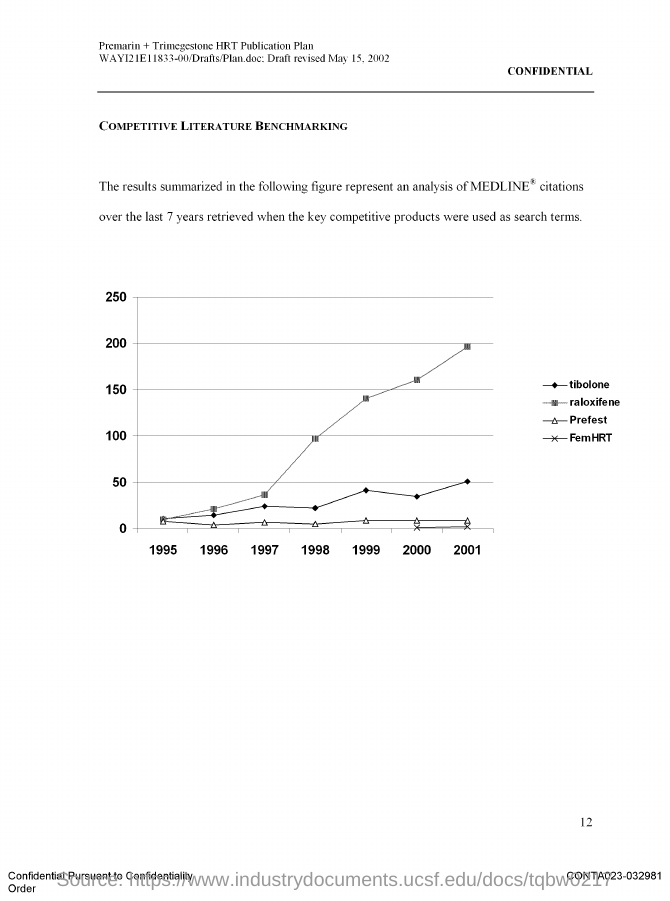Draw attention to some important aspects in this diagram. On May 15, 2002, the draft was revised. The title of the graph is 'Competitive Literature Benchmarking'. 